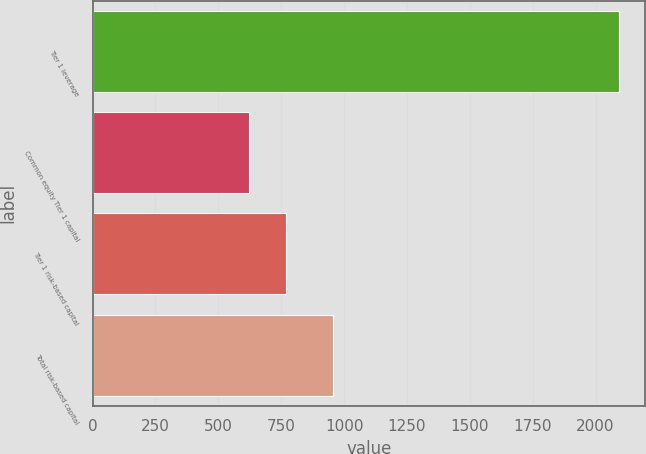<chart> <loc_0><loc_0><loc_500><loc_500><bar_chart><fcel>Tier 1 leverage<fcel>Common equity Tier 1 capital<fcel>Tier 1 risk-based capital<fcel>Total risk-based capital<nl><fcel>2093<fcel>620<fcel>767.3<fcel>954<nl></chart> 